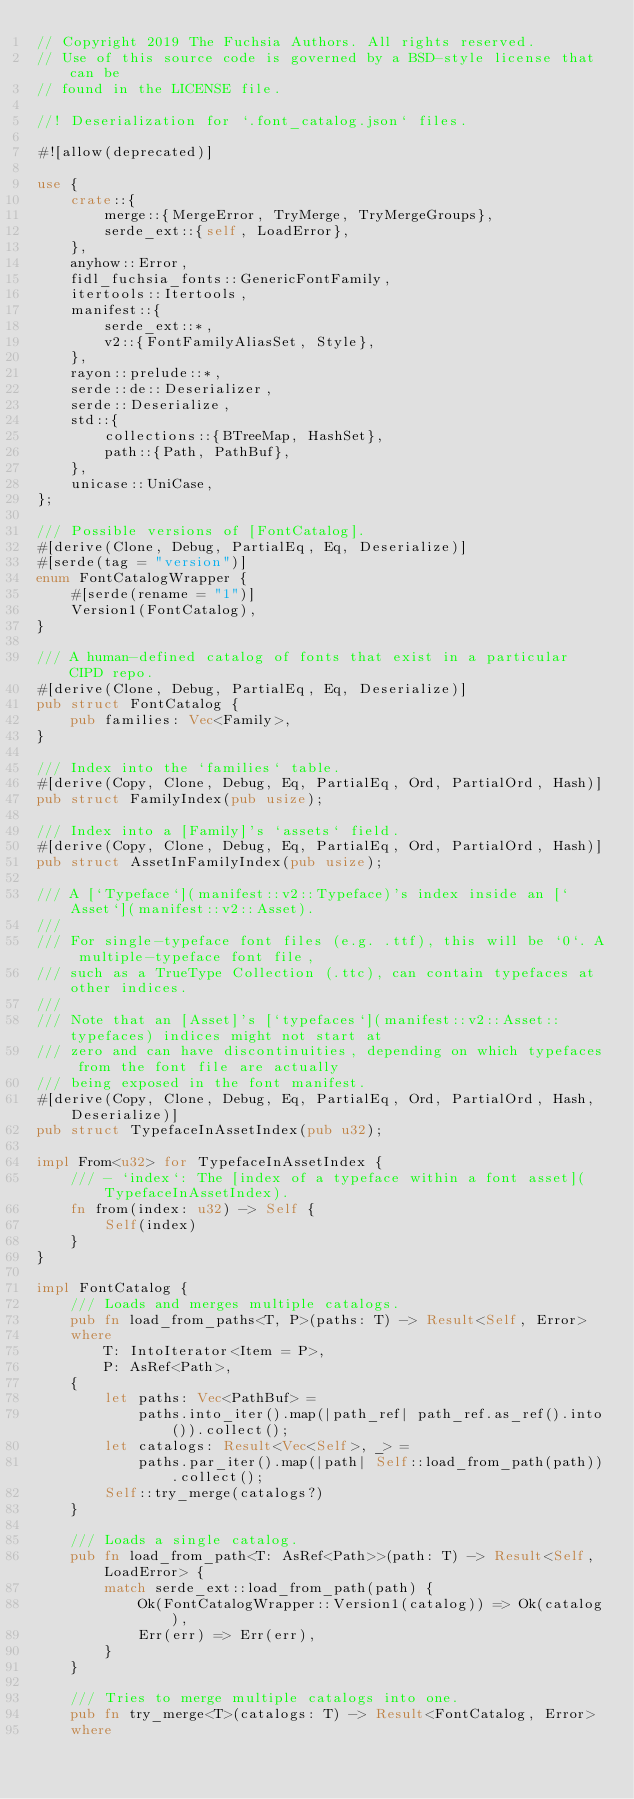<code> <loc_0><loc_0><loc_500><loc_500><_Rust_>// Copyright 2019 The Fuchsia Authors. All rights reserved.
// Use of this source code is governed by a BSD-style license that can be
// found in the LICENSE file.

//! Deserialization for `.font_catalog.json` files.

#![allow(deprecated)]

use {
    crate::{
        merge::{MergeError, TryMerge, TryMergeGroups},
        serde_ext::{self, LoadError},
    },
    anyhow::Error,
    fidl_fuchsia_fonts::GenericFontFamily,
    itertools::Itertools,
    manifest::{
        serde_ext::*,
        v2::{FontFamilyAliasSet, Style},
    },
    rayon::prelude::*,
    serde::de::Deserializer,
    serde::Deserialize,
    std::{
        collections::{BTreeMap, HashSet},
        path::{Path, PathBuf},
    },
    unicase::UniCase,
};

/// Possible versions of [FontCatalog].
#[derive(Clone, Debug, PartialEq, Eq, Deserialize)]
#[serde(tag = "version")]
enum FontCatalogWrapper {
    #[serde(rename = "1")]
    Version1(FontCatalog),
}

/// A human-defined catalog of fonts that exist in a particular CIPD repo.
#[derive(Clone, Debug, PartialEq, Eq, Deserialize)]
pub struct FontCatalog {
    pub families: Vec<Family>,
}

/// Index into the `families` table.
#[derive(Copy, Clone, Debug, Eq, PartialEq, Ord, PartialOrd, Hash)]
pub struct FamilyIndex(pub usize);

/// Index into a [Family]'s `assets` field.
#[derive(Copy, Clone, Debug, Eq, PartialEq, Ord, PartialOrd, Hash)]
pub struct AssetInFamilyIndex(pub usize);

/// A [`Typeface`](manifest::v2::Typeface)'s index inside an [`Asset`](manifest::v2::Asset).
///
/// For single-typeface font files (e.g. .ttf), this will be `0`. A multiple-typeface font file,
/// such as a TrueType Collection (.ttc), can contain typefaces at other indices.
///
/// Note that an [Asset]'s [`typefaces`](manifest::v2::Asset::typefaces) indices might not start at
/// zero and can have discontinuities, depending on which typefaces from the font file are actually
/// being exposed in the font manifest.
#[derive(Copy, Clone, Debug, Eq, PartialEq, Ord, PartialOrd, Hash, Deserialize)]
pub struct TypefaceInAssetIndex(pub u32);

impl From<u32> for TypefaceInAssetIndex {
    /// - `index`: The [index of a typeface within a font asset](TypefaceInAssetIndex).
    fn from(index: u32) -> Self {
        Self(index)
    }
}

impl FontCatalog {
    /// Loads and merges multiple catalogs.
    pub fn load_from_paths<T, P>(paths: T) -> Result<Self, Error>
    where
        T: IntoIterator<Item = P>,
        P: AsRef<Path>,
    {
        let paths: Vec<PathBuf> =
            paths.into_iter().map(|path_ref| path_ref.as_ref().into()).collect();
        let catalogs: Result<Vec<Self>, _> =
            paths.par_iter().map(|path| Self::load_from_path(path)).collect();
        Self::try_merge(catalogs?)
    }

    /// Loads a single catalog.
    pub fn load_from_path<T: AsRef<Path>>(path: T) -> Result<Self, LoadError> {
        match serde_ext::load_from_path(path) {
            Ok(FontCatalogWrapper::Version1(catalog)) => Ok(catalog),
            Err(err) => Err(err),
        }
    }

    /// Tries to merge multiple catalogs into one.
    pub fn try_merge<T>(catalogs: T) -> Result<FontCatalog, Error>
    where</code> 